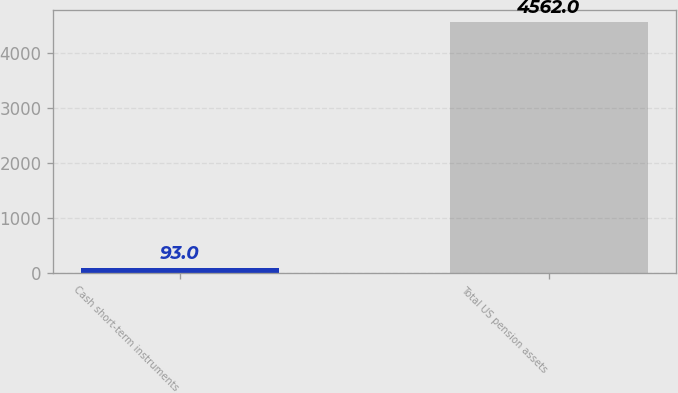Convert chart to OTSL. <chart><loc_0><loc_0><loc_500><loc_500><bar_chart><fcel>Cash short-term instruments<fcel>Total US pension assets<nl><fcel>93<fcel>4562<nl></chart> 